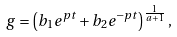<formula> <loc_0><loc_0><loc_500><loc_500>g = \left ( b _ { 1 } e ^ { p t } + b _ { 2 } e ^ { - p t } \right ) ^ { \frac { 1 } { a + 1 } } ,</formula> 